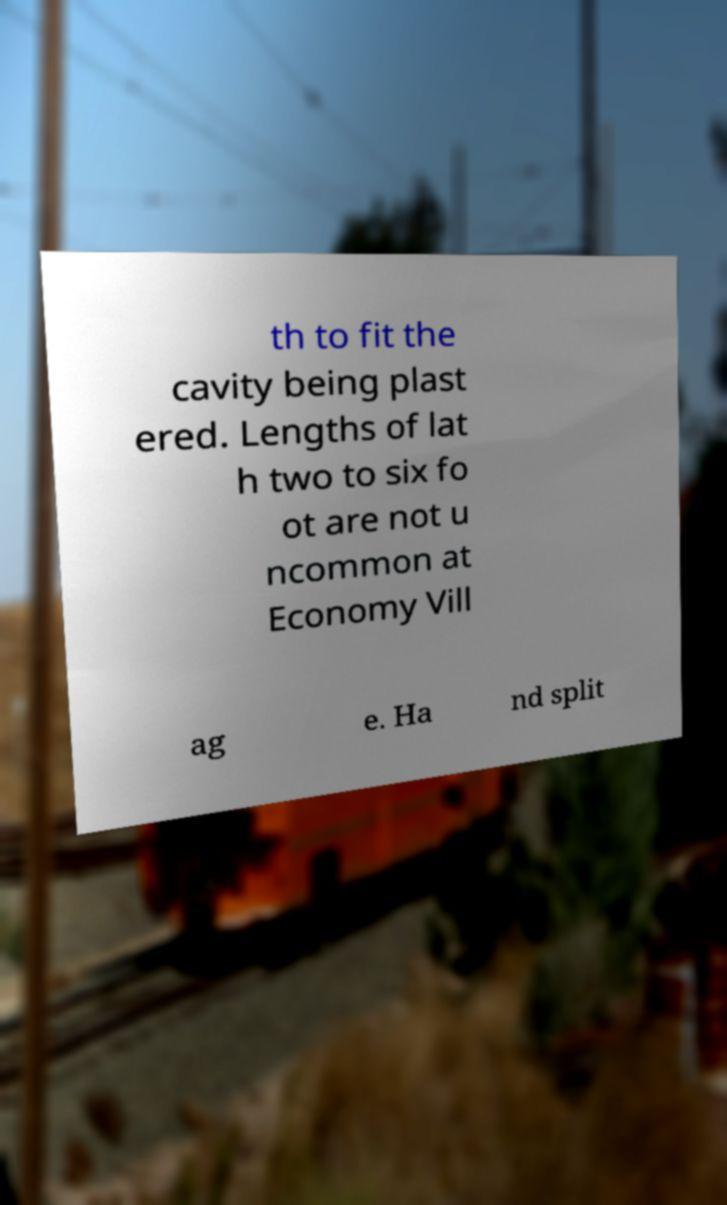What messages or text are displayed in this image? I need them in a readable, typed format. th to fit the cavity being plast ered. Lengths of lat h two to six fo ot are not u ncommon at Economy Vill ag e. Ha nd split 